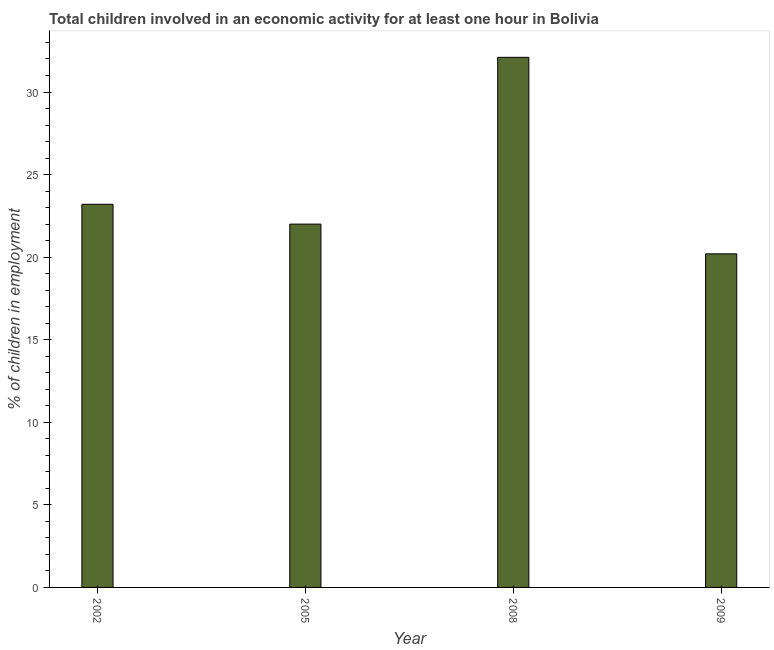Does the graph contain any zero values?
Your answer should be compact. No. What is the title of the graph?
Your response must be concise. Total children involved in an economic activity for at least one hour in Bolivia. What is the label or title of the X-axis?
Make the answer very short. Year. What is the label or title of the Y-axis?
Offer a very short reply. % of children in employment. Across all years, what is the maximum percentage of children in employment?
Your answer should be very brief. 32.1. Across all years, what is the minimum percentage of children in employment?
Provide a succinct answer. 20.2. In which year was the percentage of children in employment maximum?
Give a very brief answer. 2008. In which year was the percentage of children in employment minimum?
Offer a very short reply. 2009. What is the sum of the percentage of children in employment?
Your response must be concise. 97.5. What is the difference between the percentage of children in employment in 2002 and 2009?
Your answer should be very brief. 3. What is the average percentage of children in employment per year?
Offer a very short reply. 24.38. What is the median percentage of children in employment?
Keep it short and to the point. 22.6. In how many years, is the percentage of children in employment greater than 1 %?
Make the answer very short. 4. What is the ratio of the percentage of children in employment in 2002 to that in 2009?
Offer a terse response. 1.15. Is the percentage of children in employment in 2008 less than that in 2009?
Give a very brief answer. No. Is the sum of the percentage of children in employment in 2005 and 2009 greater than the maximum percentage of children in employment across all years?
Provide a succinct answer. Yes. What is the % of children in employment of 2002?
Your response must be concise. 23.2. What is the % of children in employment in 2008?
Provide a short and direct response. 32.1. What is the % of children in employment in 2009?
Offer a very short reply. 20.2. What is the difference between the % of children in employment in 2002 and 2008?
Your answer should be compact. -8.9. What is the difference between the % of children in employment in 2002 and 2009?
Your answer should be very brief. 3. What is the difference between the % of children in employment in 2005 and 2008?
Your response must be concise. -10.1. What is the difference between the % of children in employment in 2005 and 2009?
Your answer should be compact. 1.8. What is the difference between the % of children in employment in 2008 and 2009?
Make the answer very short. 11.9. What is the ratio of the % of children in employment in 2002 to that in 2005?
Ensure brevity in your answer.  1.05. What is the ratio of the % of children in employment in 2002 to that in 2008?
Provide a succinct answer. 0.72. What is the ratio of the % of children in employment in 2002 to that in 2009?
Offer a very short reply. 1.15. What is the ratio of the % of children in employment in 2005 to that in 2008?
Your answer should be very brief. 0.69. What is the ratio of the % of children in employment in 2005 to that in 2009?
Offer a terse response. 1.09. What is the ratio of the % of children in employment in 2008 to that in 2009?
Your response must be concise. 1.59. 